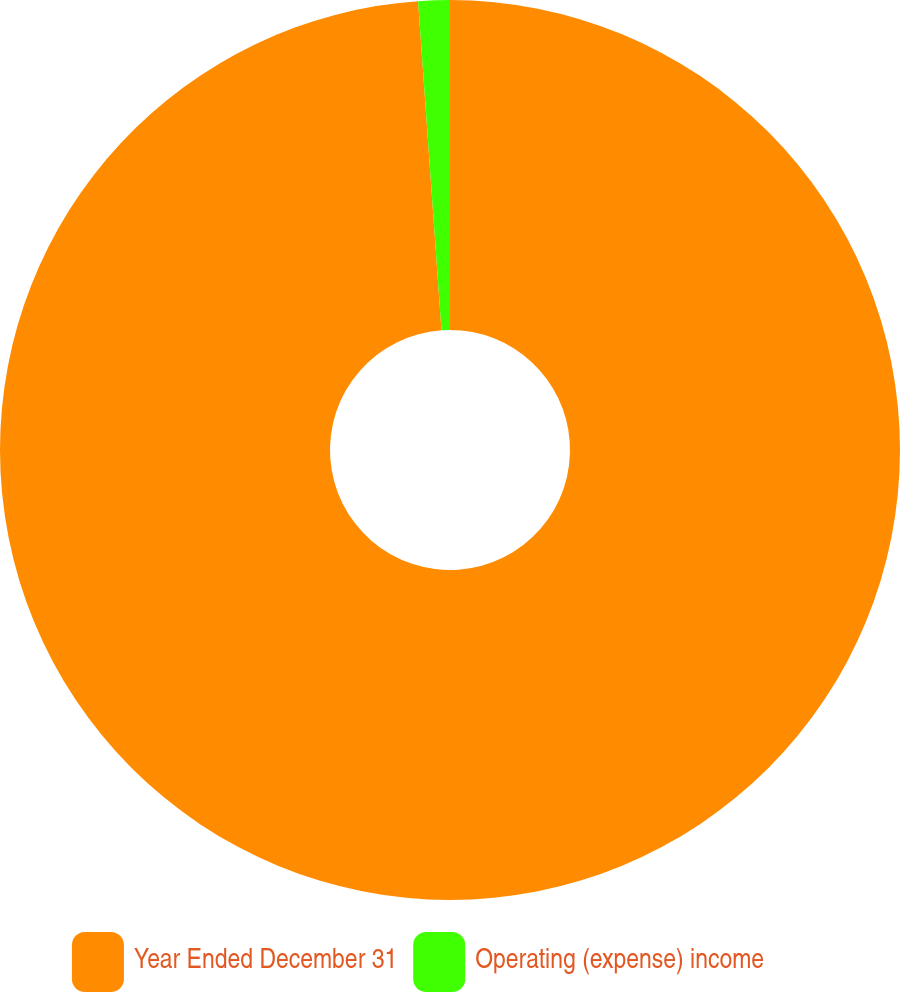Convert chart. <chart><loc_0><loc_0><loc_500><loc_500><pie_chart><fcel>Year Ended December 31<fcel>Operating (expense) income<nl><fcel>98.87%<fcel>1.13%<nl></chart> 